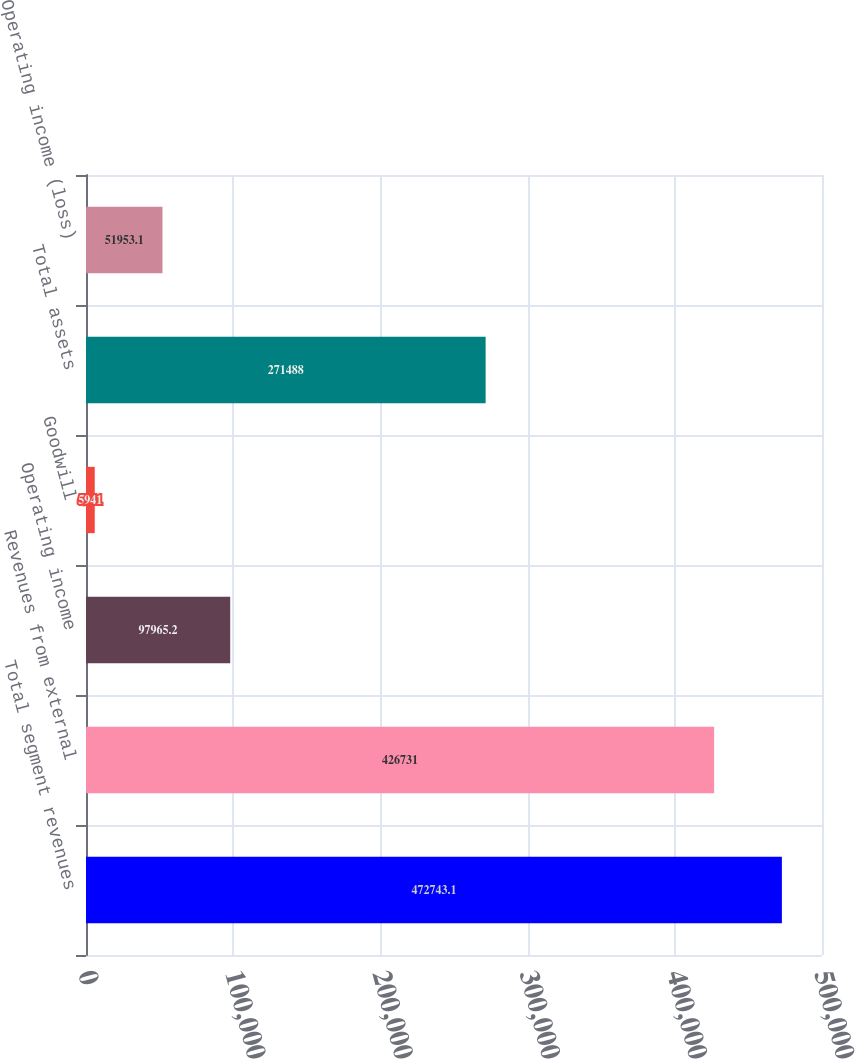Convert chart to OTSL. <chart><loc_0><loc_0><loc_500><loc_500><bar_chart><fcel>Total segment revenues<fcel>Revenues from external<fcel>Operating income<fcel>Goodwill<fcel>Total assets<fcel>Operating income (loss)<nl><fcel>472743<fcel>426731<fcel>97965.2<fcel>5941<fcel>271488<fcel>51953.1<nl></chart> 